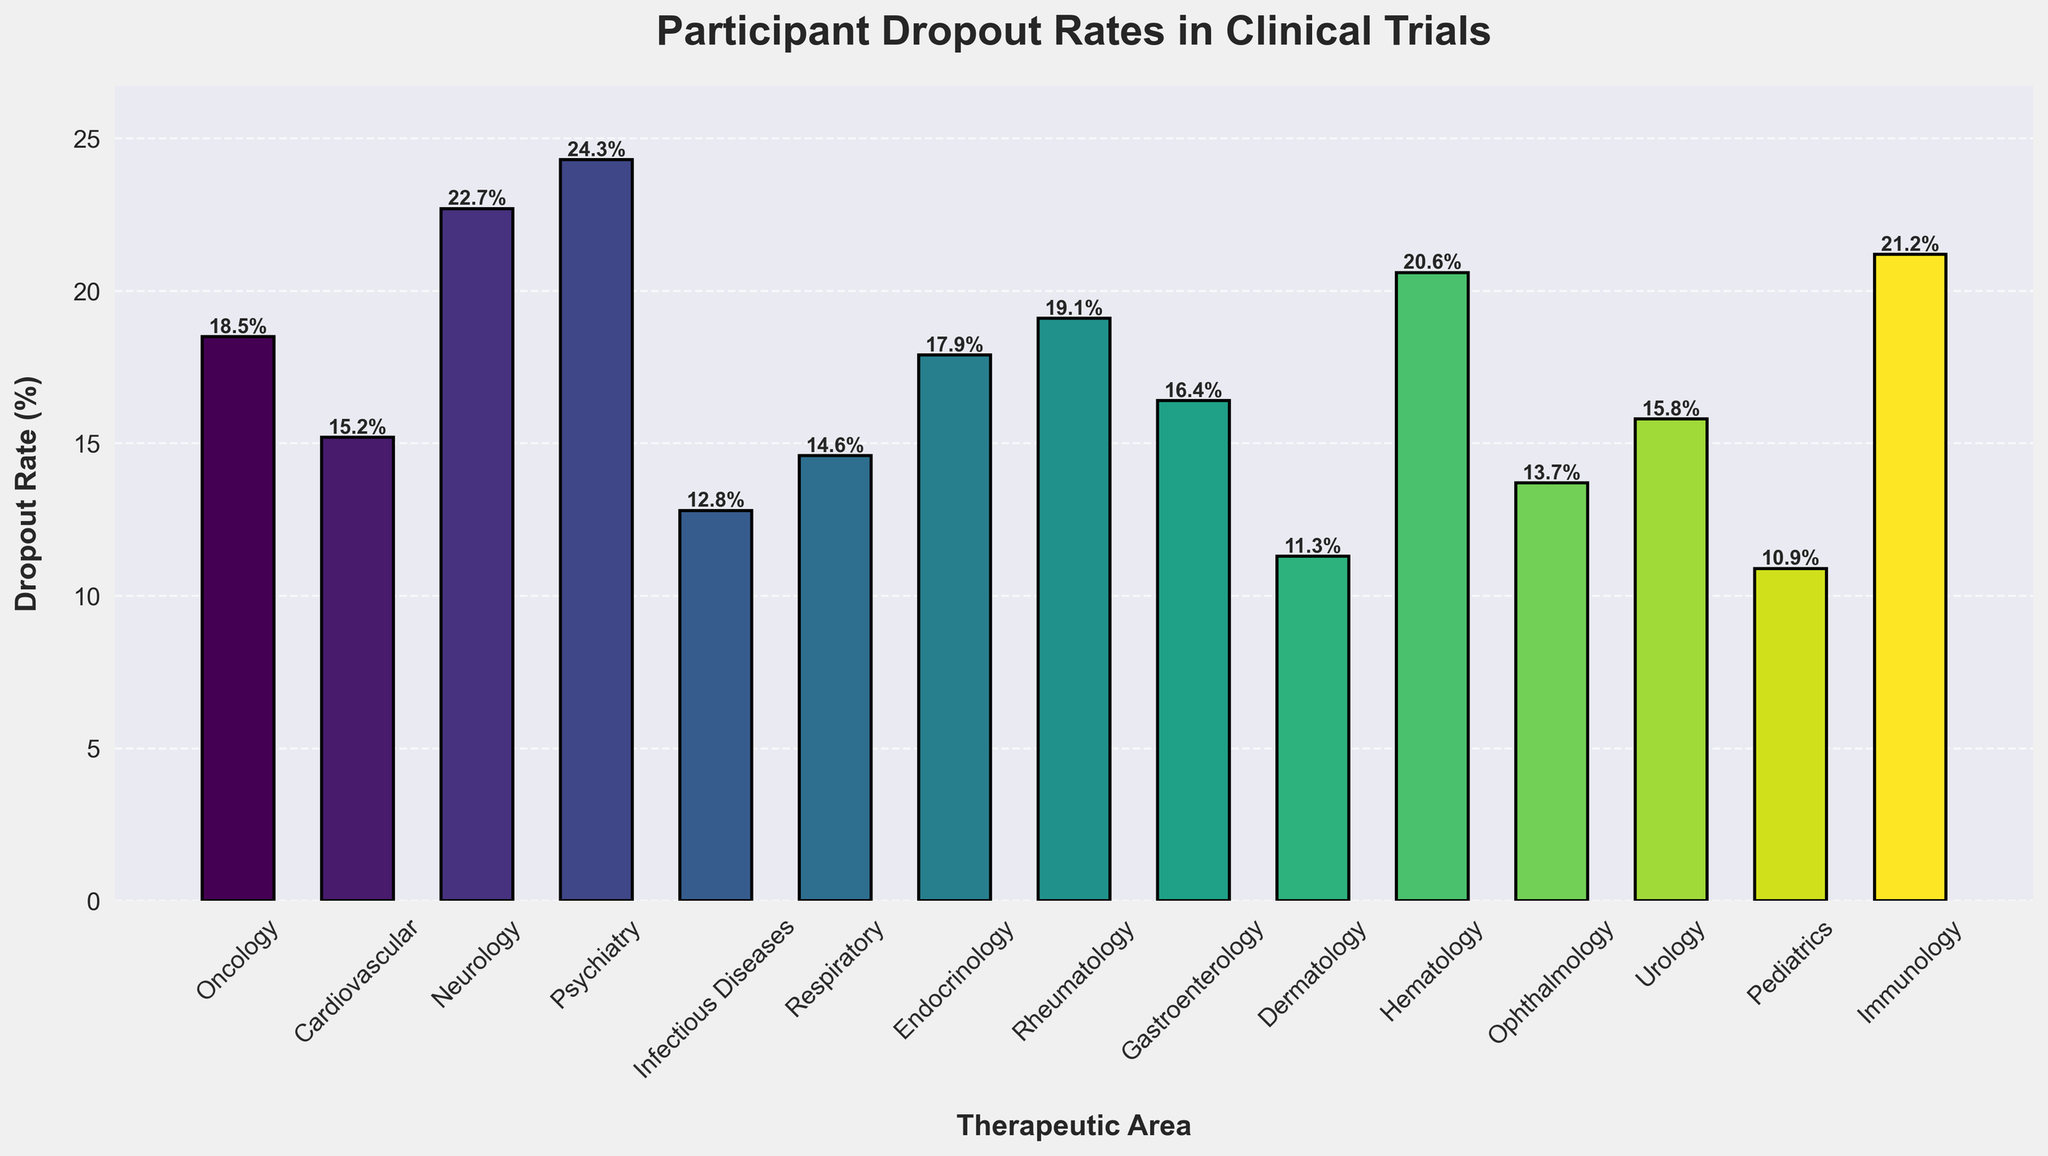Which therapeutic area has the highest dropout rate? Look for the bar with the maximum height. The tallest bar represents Psychiatry with a dropout rate of 24.3%.
Answer: Psychiatry Which therapeutic area has the lowest dropout rate? Look for the bar with the shortest height. The smallest bar represents Pediatrics with a dropout rate of 10.9%.
Answer: Pediatrics Compare the dropout rates of Oncology and Hematology. Which one is higher? Compare the heights of the bars for Oncology and Hematology. Hematology's bar is taller at 20.6%, compared to Oncology's 18.5%.
Answer: Hematology What is the average dropout rate across all therapeutic areas? Sum all dropout rates and divide by the number of therapeutic areas. (18.5 + 15.2 + 22.7 + 24.3 + 12.8 + 14.6 + 17.9 + 19.1 + 16.4 + 11.3 + 20.6 + 13.7 + 15.8 + 10.9 + 21.2) / 15 = 17.0%
Answer: 17.0% Which therapeutic areas have dropout rates greater than 20%? Identify bars with heights greater than 20%. The therapeutic areas are Neurology (22.7%), Psychiatry (24.3%), Hematology (20.6%), and Immunology (21.2%).
Answer: Neurology, Psychiatry, Hematology, Immunology Is the dropout rate for Endocrinology higher or lower than the rate for Cardiovascular? Compare the heights of the bars for Endocrinology and Cardiovascular. Endocrinology's rate is 17.9%, which is higher than Cardiovascular's 15.2%.
Answer: Higher What is the combined dropout rate for Dermatology, Ophthalmology, and Urology? Add the dropout rates for the three areas. 11.3% (Dermatology) + 13.7% (Ophthalmology) + 15.8% (Urology) = 40.8%
Answer: 40.8% Which therapeutic area has a dropout rate closest to the overall average dropout rate? First, find the overall average: 17.0%. Then, find the therapeutic area bar whose height is closest to this value. Respiratory has a dropout rate of 14.6%, which is closest.
Answer: Respiratory Compare the dropout rates of Oncology, Infectious Diseases, and Gastroenterology. Which area has the lowest rate? Compare the heights of the bars for these areas. Oncology is 18.5%, Infectious Diseases is 12.8%, and Gastroenterology is 16.4%. Infectious Diseases has the lowest dropout rate.
Answer: Infectious Diseases 